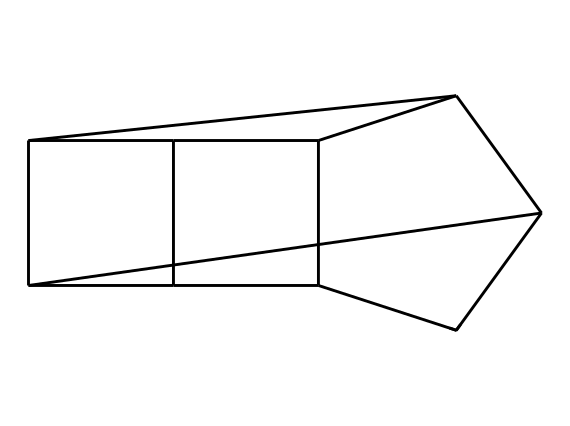What is the chemical name for this structure? The SMILES representation corresponds to adamantane, a well-known cage compound featuring a specific arrangement of carbon atoms.
Answer: adamantane How many carbon atoms are present in this structure? By analyzing the SMILES representation, it is evident that there are 10 carbon atoms forming the cage structure.
Answer: 10 What is the total number of hydrogen atoms? Each carbon typically forms four bonds; in this cage structure, after accounting for the bonding requirements, there are 16 hydrogen atoms associated with the 10 carbon atoms.
Answer: 16 What type of hybridization is present in the carbon atoms of adamantane? The carbon atoms in adamantane are sp3 hybridized, which is typical for tetrahedral carbon atoms forming saturated compounds.
Answer: sp3 How does the structure of adamantane contribute to its stability? The cage-like structure of adamantane minimizes torsional strain and steric hindrance, thus enhancing its overall stability compared to other less-nested hydrocarbons.
Answer: stability What distinguishes adamantane as a cage compound compared to other hydrocarbons? Adamantane is characterized by its unique three-dimensional cage-like arrangement of carbon atoms, which differentiates it from linear or branched hydrocarbons.
Answer: cage-like arrangement 